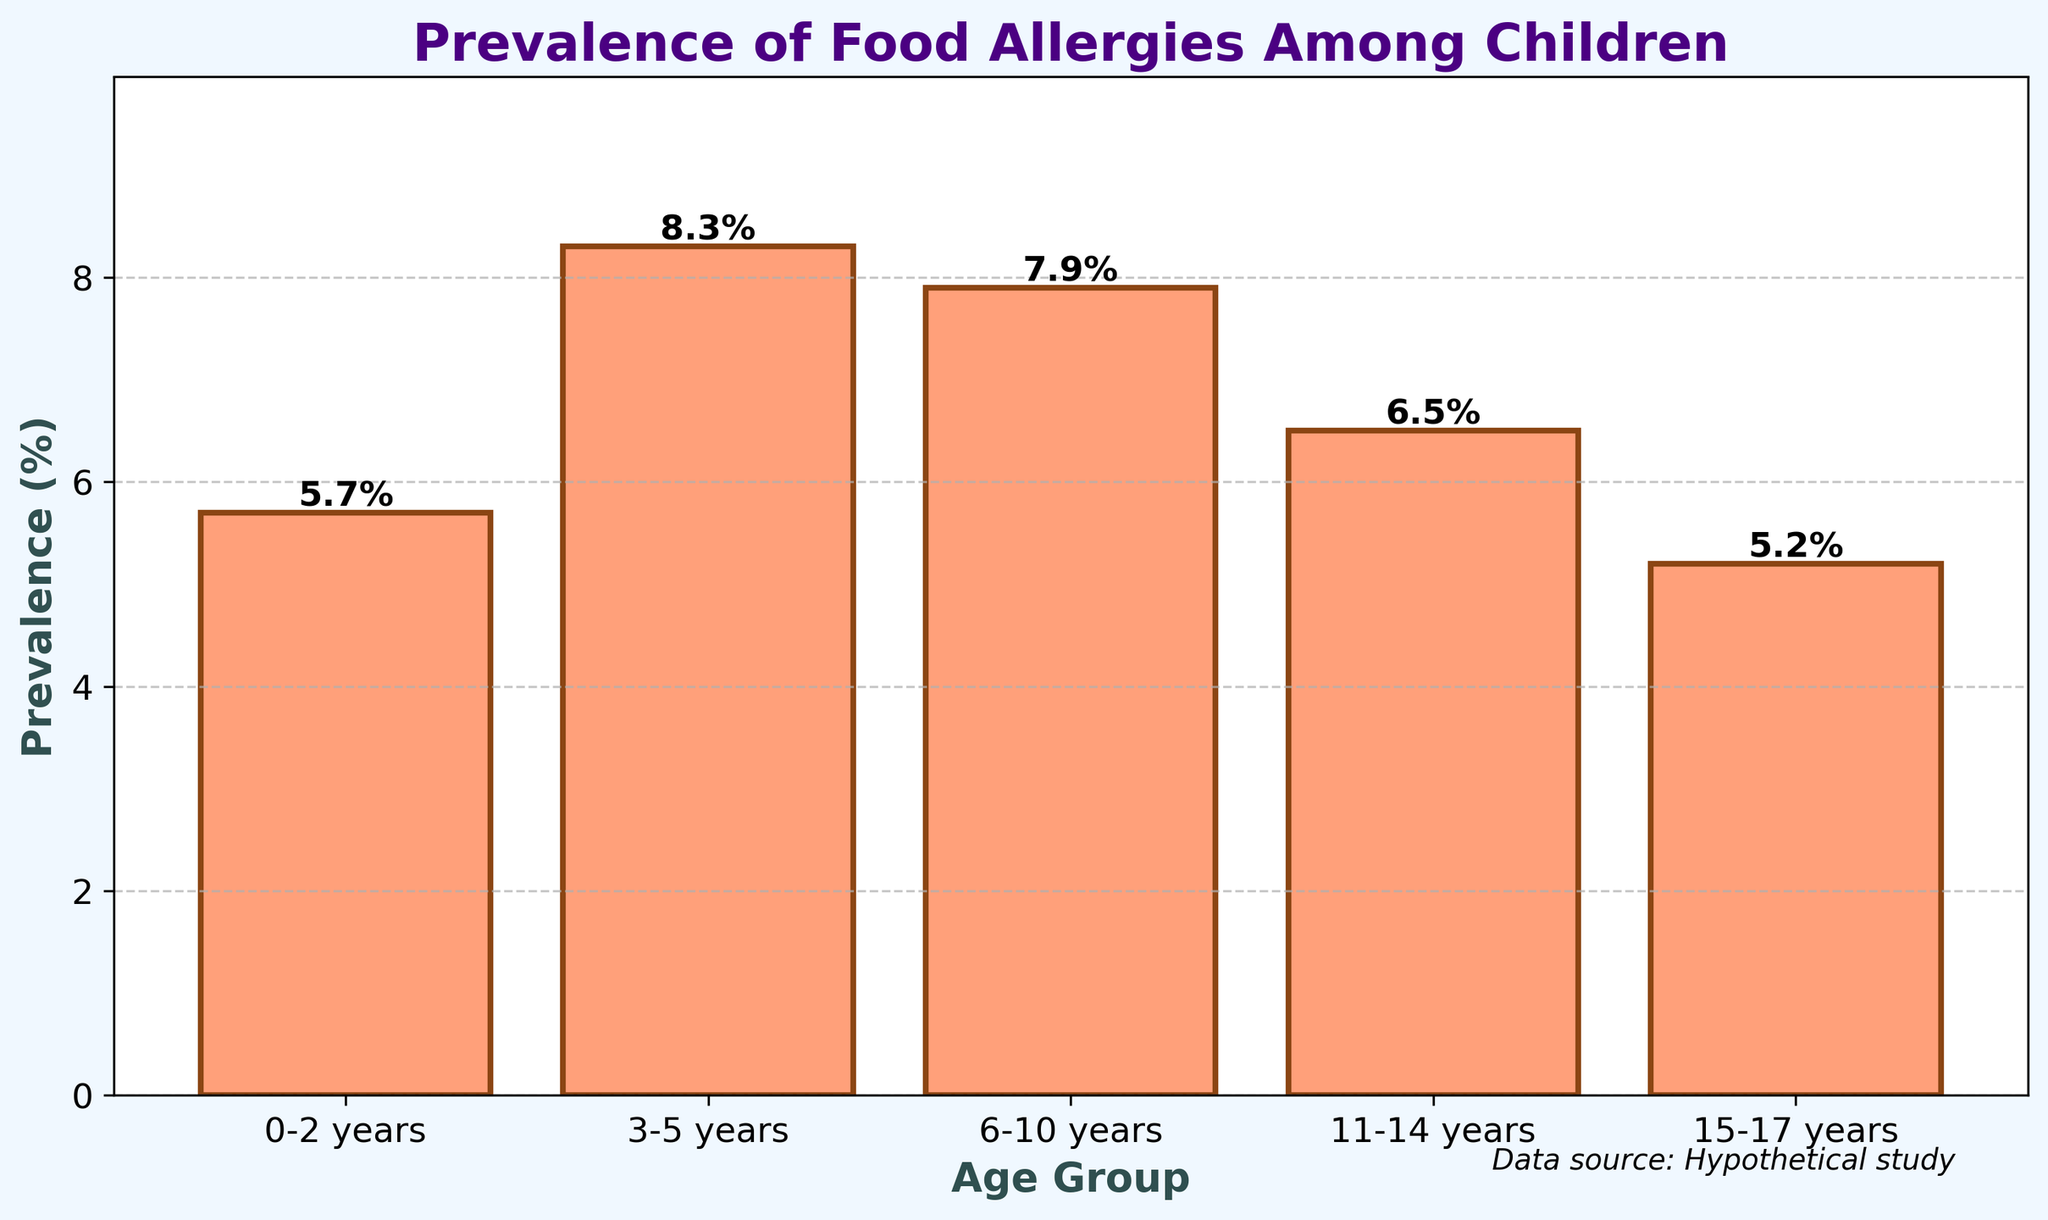Which age group has the highest prevalence of food allergies? To find the age group with the highest prevalence, look at the height of the bars. The tallest bar represents the highest prevalence. In this case, the bar for the 3-5 years age group is the tallest, indicating the highest prevalence at 8.3%.
Answer: 3-5 years Which age group has the lowest prevalence of food allergies? To determine the age group with the lowest prevalence, find the shortest bar on the chart. The bar for the 15-17 years age group is the shortest, indicating the lowest prevalence at 5.2%.
Answer: 15-17 years What is the difference in prevalence between the 3-5 years age group and the 15-17 years age group? Subtract the prevalence percentage of the 15-17 years age group from that of the 3-5 years age group. This is calculated as 8.3% - 5.2% = 3.1%.
Answer: 3.1% What is the average prevalence across all age groups? Sum all the prevalence percentages and then divide by the number of age groups. The sum is 5.7 + 8.3 + 7.9 + 6.5 + 5.2 = 33.6. Dividing by 5, the average prevalence is 33.6 / 5 = 6.72%.
Answer: 6.72% How much taller is the bar for the 3-5 years age group compared to the bar for the 11-14 years age group? Subtract the height (prevalence) of the 11-14 years bar from that of the 3-5 years bar. This is calculated as 8.3% - 6.5% = 1.8%.
Answer: 1.8% What is the range of prevalence values across the age groups? To calculate the range, subtract the smallest value from the largest value. The largest value is 8.3% and the smallest is 5.2%. The range is calculated as 8.3% - 5.2% = 3.1%.
Answer: 3.1% Which age groups have a prevalence higher than 6.5%? Identify the age groups whose prevalence bars are higher than the 6.5% mark. This includes the 3-5 years (8.3%) and the 6-10 years (7.9%) age groups.
Answer: 3-5 years, 6-10 years What is the total prevalence of the 0-2 years and 15-17 years age groups combined? Add the prevalence percentages of the 0-2 years (5.7%) and 15-17 years (5.2%) age groups together. This is calculated as 5.7% + 5.2% = 10.9%.
Answer: 10.9% Which age group shows a prevalence closest to the overall average prevalence? First, calculate the overall average prevalence, which is 6.72%. Then find the age group with a prevalence closest to this value. The age group 11-14 years has a prevalence of 6.5%, which is closest to 6.72%.
Answer: 11-14 years 